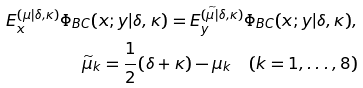<formula> <loc_0><loc_0><loc_500><loc_500>E _ { x } ^ { ( \mu | \delta , \kappa ) } \Phi _ { B C } ( x ; y | \delta , \kappa ) = E _ { y } ^ { ( \widetilde { \mu | } \delta , \kappa ) } \Phi _ { B C } ( x ; y | \delta , \kappa ) , \\ \widetilde { \mu } _ { k } = { \frac { 1 } { 2 } } ( \delta + \kappa ) - \mu _ { k } \quad ( k = 1 , \dots , 8 )</formula> 